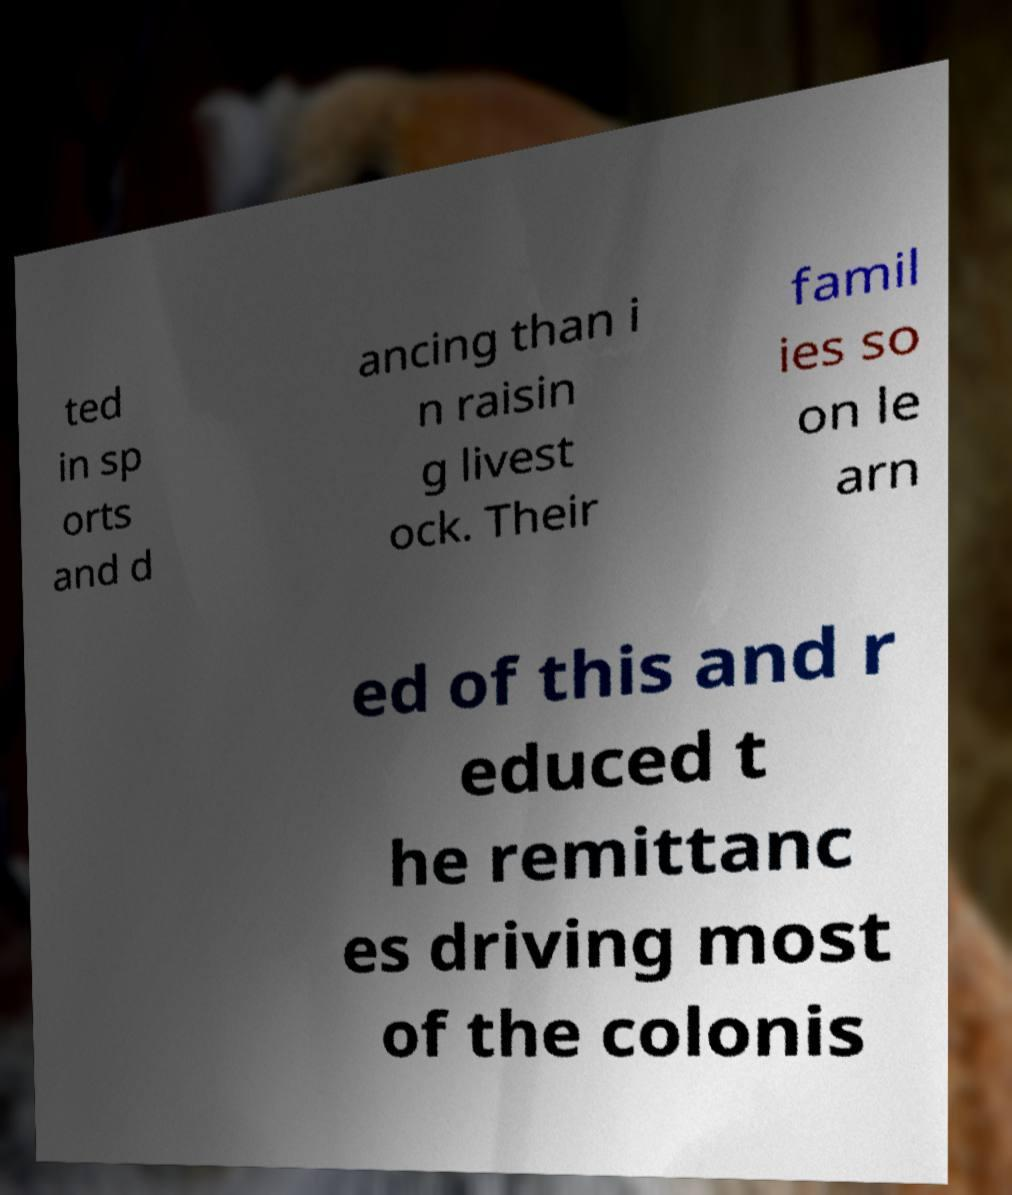I need the written content from this picture converted into text. Can you do that? ted in sp orts and d ancing than i n raisin g livest ock. Their famil ies so on le arn ed of this and r educed t he remittanc es driving most of the colonis 